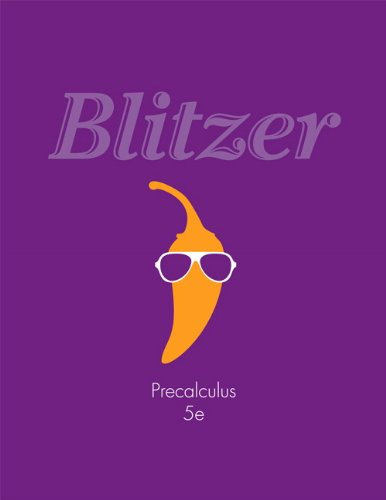Can you tell me what visual elements on the cover suggest about the style of the textbook? The cover features a playful design with a chili pepper wearing sunglasses, which suggests that the author might have a fun and informal approach to presenting complex mathematical concepts, making them more accessible to students. 